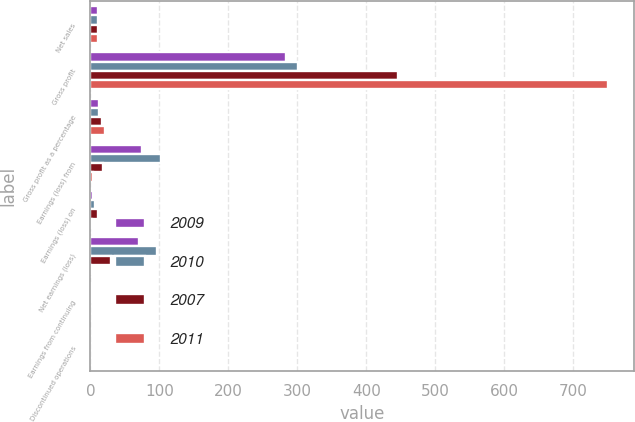<chart> <loc_0><loc_0><loc_500><loc_500><stacked_bar_chart><ecel><fcel>Net sales<fcel>Gross profit<fcel>Gross profit as a percentage<fcel>Earnings (loss) from<fcel>Earnings (loss) on<fcel>Net earnings (loss)<fcel>Earnings from continuing<fcel>Discontinued operations<nl><fcel>2009<fcel>11.75<fcel>283.9<fcel>11.8<fcel>75.3<fcel>4.5<fcel>70.8<fcel>0.58<fcel>0.03<nl><fcel>2010<fcel>11.75<fcel>300.7<fcel>12.5<fcel>102.5<fcel>6<fcel>96.5<fcel>0.8<fcel>0.05<nl><fcel>2007<fcel>11.75<fcel>446<fcel>17.5<fcel>18.6<fcel>11.7<fcel>30.3<fcel>0.16<fcel>0.09<nl><fcel>2011<fcel>11.75<fcel>749.7<fcel>21.7<fcel>3.4<fcel>2.4<fcel>0.9<fcel>0.03<fcel>0.02<nl></chart> 